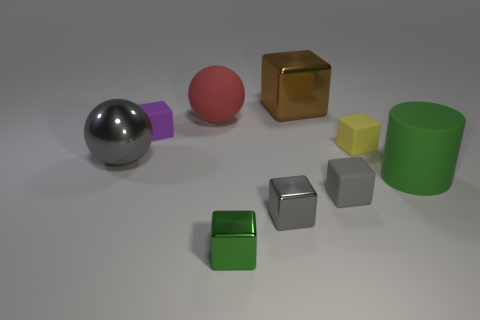How are the objects arranged in this scene? The objects are arranged sporadically on a flat surface, with various geometric shapes such as spheres, cubes, and cylinders present. The arrangement seems carefully spaced, with no particular pattern, giving the impression of an orderly randomness often used in aesthetic displays. 